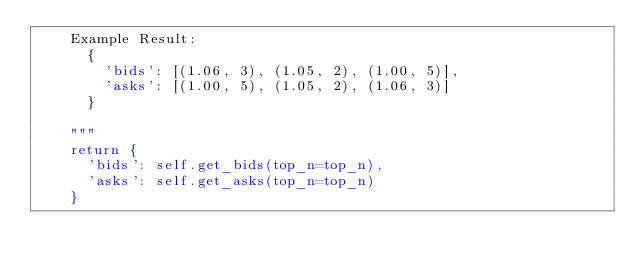<code> <loc_0><loc_0><loc_500><loc_500><_Python_>    Example Result:
      {
        'bids': [(1.06, 3), (1.05, 2), (1.00, 5)],
        'asks': [(1.00, 5), (1.05, 2), (1.06, 3)]
      }

    """
    return {
      'bids': self.get_bids(top_n=top_n),
      'asks': self.get_asks(top_n=top_n)
    }

</code> 